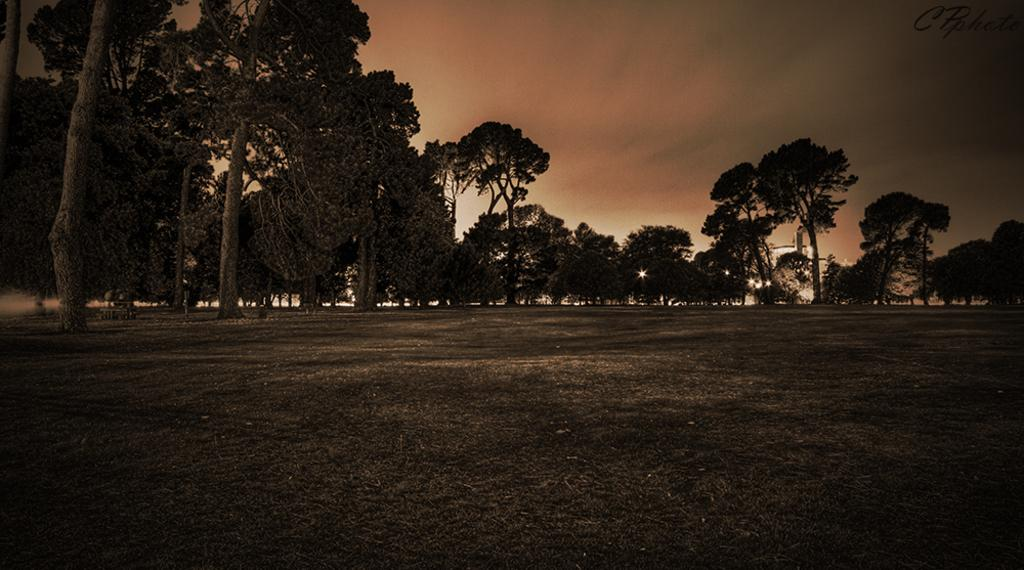What type of terrain is visible in the image? There is an open grass ground in the image. What can be seen in the background of the image? There are trees and the sky visible in the background of the image. Is there any text or marking on the image? Yes, there is a watermark in the top right corner of the image. What type of bomb can be seen falling from the sky in the image? There is no bomb present in the image; it features an open grass ground with trees and the sky visible in the background. What type of thunder can be heard in the image? The image is a still picture and does not have any sound, so it is not possible to hear thunder in the image. 